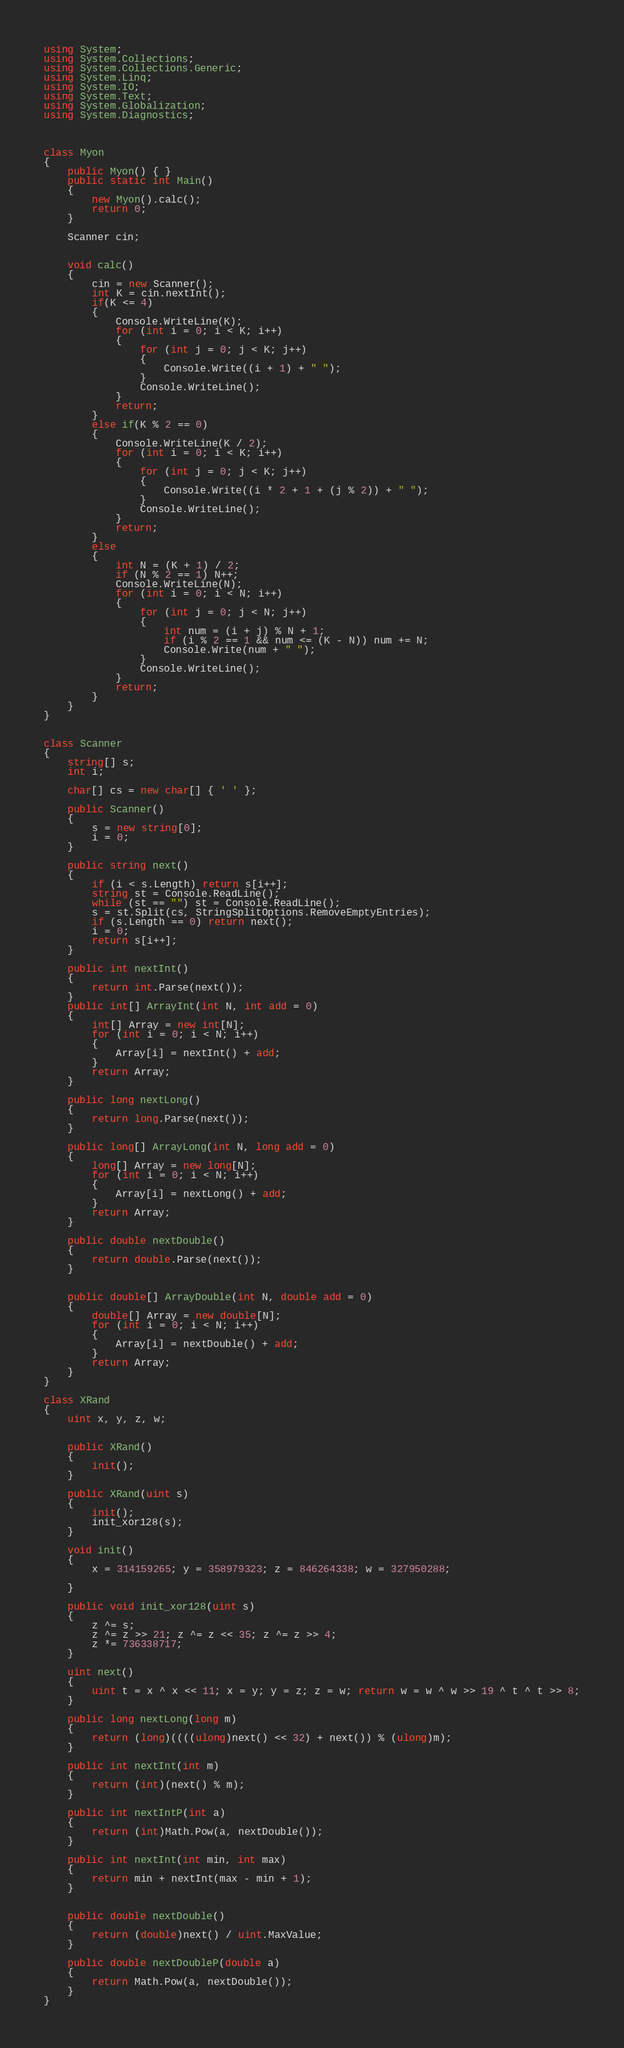Convert code to text. <code><loc_0><loc_0><loc_500><loc_500><_C#_>using System;
using System.Collections;
using System.Collections.Generic;
using System.Linq;
using System.IO;
using System.Text;
using System.Globalization;
using System.Diagnostics;



class Myon
{
    public Myon() { }
    public static int Main()
    {
        new Myon().calc();
        return 0;
    }

    Scanner cin;
    

    void calc()
    {
        cin = new Scanner();
        int K = cin.nextInt();
        if(K <= 4)
        {
            Console.WriteLine(K);
            for (int i = 0; i < K; i++)
            {
                for (int j = 0; j < K; j++)
                {
                    Console.Write((i + 1) + " ");
                }
                Console.WriteLine();
            }
            return;
        }
        else if(K % 2 == 0)
        {
            Console.WriteLine(K / 2);
            for (int i = 0; i < K; i++)
            {
                for (int j = 0; j < K; j++)
                {
                    Console.Write((i * 2 + 1 + (j % 2)) + " ");
                }
                Console.WriteLine();
            }
            return;
        }
        else
        {
            int N = (K + 1) / 2;
            if (N % 2 == 1) N++;
            Console.WriteLine(N);
            for (int i = 0; i < N; i++)
            {
                for (int j = 0; j < N; j++)
                {
                    int num = (i + j) % N + 1;
                    if (i % 2 == 1 && num <= (K - N)) num += N;
                    Console.Write(num + " ");
                }
                Console.WriteLine();
            }
            return;
        }
    }
}


class Scanner
{
    string[] s;
    int i;

    char[] cs = new char[] { ' ' };

    public Scanner()
    {
        s = new string[0];
        i = 0;
    }

    public string next()
    {
        if (i < s.Length) return s[i++];
        string st = Console.ReadLine();
        while (st == "") st = Console.ReadLine();
        s = st.Split(cs, StringSplitOptions.RemoveEmptyEntries);
        if (s.Length == 0) return next();
        i = 0;
        return s[i++];
    }

    public int nextInt()
    {
        return int.Parse(next());
    }
    public int[] ArrayInt(int N, int add = 0)
    {
        int[] Array = new int[N];
        for (int i = 0; i < N; i++)
        {
            Array[i] = nextInt() + add;
        }
        return Array;
    }

    public long nextLong()
    {
        return long.Parse(next());
    }

    public long[] ArrayLong(int N, long add = 0)
    {
        long[] Array = new long[N];
        for (int i = 0; i < N; i++)
        {
            Array[i] = nextLong() + add;
        }
        return Array;
    }

    public double nextDouble()
    {
        return double.Parse(next());
    }


    public double[] ArrayDouble(int N, double add = 0)
    {
        double[] Array = new double[N];
        for (int i = 0; i < N; i++)
        {
            Array[i] = nextDouble() + add;
        }
        return Array;
    }
}

class XRand
{
    uint x, y, z, w;


    public XRand()
    {
        init();
    }

    public XRand(uint s)
    {
        init();
        init_xor128(s);
    }

    void init()
    {
        x = 314159265; y = 358979323; z = 846264338; w = 327950288;

    }

    public void init_xor128(uint s)
    {
        z ^= s;
        z ^= z >> 21; z ^= z << 35; z ^= z >> 4;
        z *= 736338717;
    }

    uint next()
    {
        uint t = x ^ x << 11; x = y; y = z; z = w; return w = w ^ w >> 19 ^ t ^ t >> 8;
    }

    public long nextLong(long m)
    {
        return (long)((((ulong)next() << 32) + next()) % (ulong)m);
    }

    public int nextInt(int m)
    {
        return (int)(next() % m);
    }

    public int nextIntP(int a)
    {
        return (int)Math.Pow(a, nextDouble());
    }

    public int nextInt(int min, int max)
    {
        return min + nextInt(max - min + 1);
    }


    public double nextDouble()
    {
        return (double)next() / uint.MaxValue;
    }

    public double nextDoubleP(double a)
    {
        return Math.Pow(a, nextDouble());
    }
}

</code> 